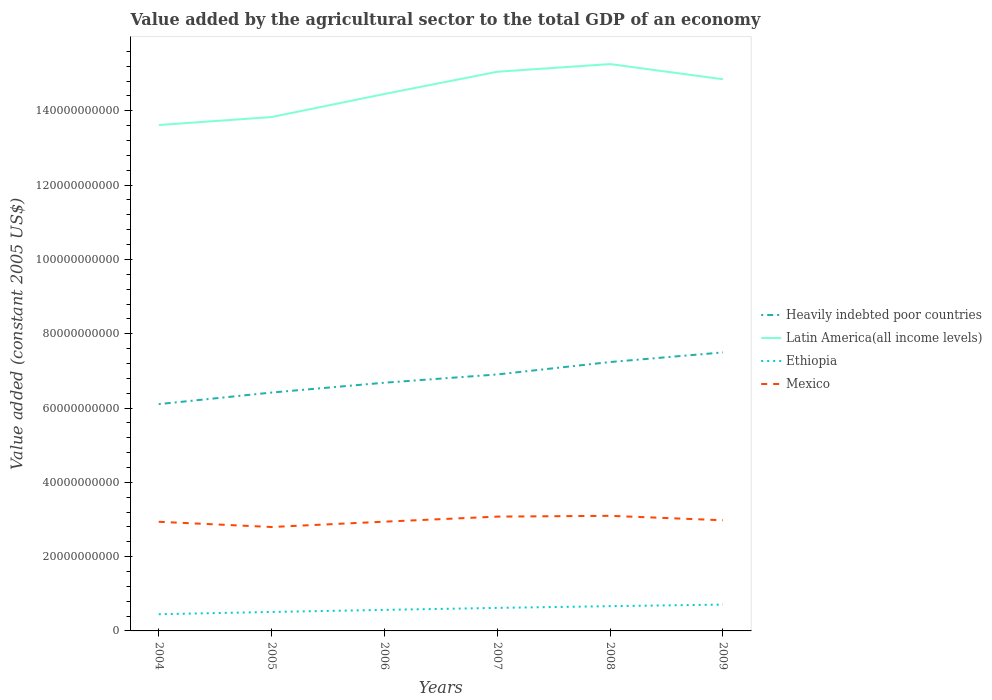Is the number of lines equal to the number of legend labels?
Offer a very short reply. Yes. Across all years, what is the maximum value added by the agricultural sector in Heavily indebted poor countries?
Make the answer very short. 6.10e+1. In which year was the value added by the agricultural sector in Mexico maximum?
Keep it short and to the point. 2005. What is the total value added by the agricultural sector in Mexico in the graph?
Keep it short and to the point. -2.11e+08. What is the difference between the highest and the second highest value added by the agricultural sector in Heavily indebted poor countries?
Offer a terse response. 1.39e+1. What is the difference between two consecutive major ticks on the Y-axis?
Ensure brevity in your answer.  2.00e+1. Where does the legend appear in the graph?
Your answer should be very brief. Center right. How many legend labels are there?
Your response must be concise. 4. What is the title of the graph?
Ensure brevity in your answer.  Value added by the agricultural sector to the total GDP of an economy. Does "Niger" appear as one of the legend labels in the graph?
Give a very brief answer. No. What is the label or title of the X-axis?
Provide a short and direct response. Years. What is the label or title of the Y-axis?
Offer a very short reply. Value added (constant 2005 US$). What is the Value added (constant 2005 US$) of Heavily indebted poor countries in 2004?
Give a very brief answer. 6.10e+1. What is the Value added (constant 2005 US$) in Latin America(all income levels) in 2004?
Give a very brief answer. 1.36e+11. What is the Value added (constant 2005 US$) in Ethiopia in 2004?
Your answer should be compact. 4.50e+09. What is the Value added (constant 2005 US$) in Mexico in 2004?
Offer a terse response. 2.94e+1. What is the Value added (constant 2005 US$) in Heavily indebted poor countries in 2005?
Provide a succinct answer. 6.42e+1. What is the Value added (constant 2005 US$) of Latin America(all income levels) in 2005?
Keep it short and to the point. 1.38e+11. What is the Value added (constant 2005 US$) of Ethiopia in 2005?
Keep it short and to the point. 5.11e+09. What is the Value added (constant 2005 US$) of Mexico in 2005?
Make the answer very short. 2.80e+1. What is the Value added (constant 2005 US$) of Heavily indebted poor countries in 2006?
Your response must be concise. 6.68e+1. What is the Value added (constant 2005 US$) in Latin America(all income levels) in 2006?
Provide a short and direct response. 1.45e+11. What is the Value added (constant 2005 US$) of Ethiopia in 2006?
Offer a terse response. 5.66e+09. What is the Value added (constant 2005 US$) in Mexico in 2006?
Your answer should be compact. 2.94e+1. What is the Value added (constant 2005 US$) of Heavily indebted poor countries in 2007?
Ensure brevity in your answer.  6.90e+1. What is the Value added (constant 2005 US$) of Latin America(all income levels) in 2007?
Ensure brevity in your answer.  1.51e+11. What is the Value added (constant 2005 US$) of Ethiopia in 2007?
Keep it short and to the point. 6.20e+09. What is the Value added (constant 2005 US$) in Mexico in 2007?
Ensure brevity in your answer.  3.08e+1. What is the Value added (constant 2005 US$) of Heavily indebted poor countries in 2008?
Ensure brevity in your answer.  7.24e+1. What is the Value added (constant 2005 US$) in Latin America(all income levels) in 2008?
Make the answer very short. 1.53e+11. What is the Value added (constant 2005 US$) in Ethiopia in 2008?
Give a very brief answer. 6.66e+09. What is the Value added (constant 2005 US$) in Mexico in 2008?
Make the answer very short. 3.10e+1. What is the Value added (constant 2005 US$) of Heavily indebted poor countries in 2009?
Your answer should be very brief. 7.50e+1. What is the Value added (constant 2005 US$) in Latin America(all income levels) in 2009?
Keep it short and to the point. 1.48e+11. What is the Value added (constant 2005 US$) in Ethiopia in 2009?
Make the answer very short. 7.09e+09. What is the Value added (constant 2005 US$) of Mexico in 2009?
Offer a terse response. 2.98e+1. Across all years, what is the maximum Value added (constant 2005 US$) of Heavily indebted poor countries?
Provide a succinct answer. 7.50e+1. Across all years, what is the maximum Value added (constant 2005 US$) in Latin America(all income levels)?
Your response must be concise. 1.53e+11. Across all years, what is the maximum Value added (constant 2005 US$) of Ethiopia?
Your response must be concise. 7.09e+09. Across all years, what is the maximum Value added (constant 2005 US$) in Mexico?
Give a very brief answer. 3.10e+1. Across all years, what is the minimum Value added (constant 2005 US$) of Heavily indebted poor countries?
Ensure brevity in your answer.  6.10e+1. Across all years, what is the minimum Value added (constant 2005 US$) of Latin America(all income levels)?
Give a very brief answer. 1.36e+11. Across all years, what is the minimum Value added (constant 2005 US$) of Ethiopia?
Your response must be concise. 4.50e+09. Across all years, what is the minimum Value added (constant 2005 US$) in Mexico?
Provide a short and direct response. 2.80e+1. What is the total Value added (constant 2005 US$) in Heavily indebted poor countries in the graph?
Give a very brief answer. 4.08e+11. What is the total Value added (constant 2005 US$) of Latin America(all income levels) in the graph?
Your answer should be very brief. 8.71e+11. What is the total Value added (constant 2005 US$) in Ethiopia in the graph?
Offer a very short reply. 3.52e+1. What is the total Value added (constant 2005 US$) in Mexico in the graph?
Ensure brevity in your answer.  1.78e+11. What is the difference between the Value added (constant 2005 US$) in Heavily indebted poor countries in 2004 and that in 2005?
Your answer should be very brief. -3.12e+09. What is the difference between the Value added (constant 2005 US$) of Latin America(all income levels) in 2004 and that in 2005?
Your answer should be very brief. -2.15e+09. What is the difference between the Value added (constant 2005 US$) of Ethiopia in 2004 and that in 2005?
Provide a succinct answer. -6.09e+08. What is the difference between the Value added (constant 2005 US$) of Mexico in 2004 and that in 2005?
Offer a terse response. 1.40e+09. What is the difference between the Value added (constant 2005 US$) of Heavily indebted poor countries in 2004 and that in 2006?
Ensure brevity in your answer.  -5.77e+09. What is the difference between the Value added (constant 2005 US$) of Latin America(all income levels) in 2004 and that in 2006?
Provide a short and direct response. -8.36e+09. What is the difference between the Value added (constant 2005 US$) of Ethiopia in 2004 and that in 2006?
Keep it short and to the point. -1.17e+09. What is the difference between the Value added (constant 2005 US$) in Mexico in 2004 and that in 2006?
Offer a terse response. -3.12e+07. What is the difference between the Value added (constant 2005 US$) in Heavily indebted poor countries in 2004 and that in 2007?
Give a very brief answer. -7.99e+09. What is the difference between the Value added (constant 2005 US$) in Latin America(all income levels) in 2004 and that in 2007?
Give a very brief answer. -1.43e+1. What is the difference between the Value added (constant 2005 US$) of Ethiopia in 2004 and that in 2007?
Keep it short and to the point. -1.70e+09. What is the difference between the Value added (constant 2005 US$) of Mexico in 2004 and that in 2007?
Your answer should be compact. -1.39e+09. What is the difference between the Value added (constant 2005 US$) of Heavily indebted poor countries in 2004 and that in 2008?
Provide a succinct answer. -1.13e+1. What is the difference between the Value added (constant 2005 US$) of Latin America(all income levels) in 2004 and that in 2008?
Offer a very short reply. -1.64e+1. What is the difference between the Value added (constant 2005 US$) in Ethiopia in 2004 and that in 2008?
Give a very brief answer. -2.17e+09. What is the difference between the Value added (constant 2005 US$) in Mexico in 2004 and that in 2008?
Keep it short and to the point. -1.60e+09. What is the difference between the Value added (constant 2005 US$) in Heavily indebted poor countries in 2004 and that in 2009?
Your response must be concise. -1.39e+1. What is the difference between the Value added (constant 2005 US$) in Latin America(all income levels) in 2004 and that in 2009?
Your response must be concise. -1.23e+1. What is the difference between the Value added (constant 2005 US$) of Ethiopia in 2004 and that in 2009?
Offer a terse response. -2.59e+09. What is the difference between the Value added (constant 2005 US$) of Mexico in 2004 and that in 2009?
Make the answer very short. -4.10e+08. What is the difference between the Value added (constant 2005 US$) in Heavily indebted poor countries in 2005 and that in 2006?
Make the answer very short. -2.65e+09. What is the difference between the Value added (constant 2005 US$) of Latin America(all income levels) in 2005 and that in 2006?
Keep it short and to the point. -6.21e+09. What is the difference between the Value added (constant 2005 US$) of Ethiopia in 2005 and that in 2006?
Provide a succinct answer. -5.57e+08. What is the difference between the Value added (constant 2005 US$) in Mexico in 2005 and that in 2006?
Offer a very short reply. -1.44e+09. What is the difference between the Value added (constant 2005 US$) in Heavily indebted poor countries in 2005 and that in 2007?
Your answer should be compact. -4.87e+09. What is the difference between the Value added (constant 2005 US$) of Latin America(all income levels) in 2005 and that in 2007?
Your answer should be very brief. -1.22e+1. What is the difference between the Value added (constant 2005 US$) in Ethiopia in 2005 and that in 2007?
Provide a short and direct response. -1.09e+09. What is the difference between the Value added (constant 2005 US$) in Mexico in 2005 and that in 2007?
Your response must be concise. -2.80e+09. What is the difference between the Value added (constant 2005 US$) in Heavily indebted poor countries in 2005 and that in 2008?
Offer a terse response. -8.21e+09. What is the difference between the Value added (constant 2005 US$) of Latin America(all income levels) in 2005 and that in 2008?
Your answer should be compact. -1.43e+1. What is the difference between the Value added (constant 2005 US$) of Ethiopia in 2005 and that in 2008?
Your response must be concise. -1.56e+09. What is the difference between the Value added (constant 2005 US$) in Mexico in 2005 and that in 2008?
Offer a terse response. -3.01e+09. What is the difference between the Value added (constant 2005 US$) in Heavily indebted poor countries in 2005 and that in 2009?
Make the answer very short. -1.08e+1. What is the difference between the Value added (constant 2005 US$) in Latin America(all income levels) in 2005 and that in 2009?
Your answer should be compact. -1.02e+1. What is the difference between the Value added (constant 2005 US$) in Ethiopia in 2005 and that in 2009?
Give a very brief answer. -1.98e+09. What is the difference between the Value added (constant 2005 US$) in Mexico in 2005 and that in 2009?
Your answer should be very brief. -1.81e+09. What is the difference between the Value added (constant 2005 US$) in Heavily indebted poor countries in 2006 and that in 2007?
Offer a terse response. -2.22e+09. What is the difference between the Value added (constant 2005 US$) in Latin America(all income levels) in 2006 and that in 2007?
Offer a terse response. -5.98e+09. What is the difference between the Value added (constant 2005 US$) in Ethiopia in 2006 and that in 2007?
Your response must be concise. -5.35e+08. What is the difference between the Value added (constant 2005 US$) of Mexico in 2006 and that in 2007?
Offer a very short reply. -1.36e+09. What is the difference between the Value added (constant 2005 US$) of Heavily indebted poor countries in 2006 and that in 2008?
Your answer should be very brief. -5.57e+09. What is the difference between the Value added (constant 2005 US$) in Latin America(all income levels) in 2006 and that in 2008?
Your answer should be compact. -8.05e+09. What is the difference between the Value added (constant 2005 US$) of Ethiopia in 2006 and that in 2008?
Keep it short and to the point. -1.00e+09. What is the difference between the Value added (constant 2005 US$) in Mexico in 2006 and that in 2008?
Your answer should be very brief. -1.57e+09. What is the difference between the Value added (constant 2005 US$) of Heavily indebted poor countries in 2006 and that in 2009?
Ensure brevity in your answer.  -8.16e+09. What is the difference between the Value added (constant 2005 US$) of Latin America(all income levels) in 2006 and that in 2009?
Make the answer very short. -3.96e+09. What is the difference between the Value added (constant 2005 US$) of Ethiopia in 2006 and that in 2009?
Provide a succinct answer. -1.42e+09. What is the difference between the Value added (constant 2005 US$) in Mexico in 2006 and that in 2009?
Your response must be concise. -3.79e+08. What is the difference between the Value added (constant 2005 US$) in Heavily indebted poor countries in 2007 and that in 2008?
Ensure brevity in your answer.  -3.34e+09. What is the difference between the Value added (constant 2005 US$) in Latin America(all income levels) in 2007 and that in 2008?
Provide a short and direct response. -2.07e+09. What is the difference between the Value added (constant 2005 US$) of Ethiopia in 2007 and that in 2008?
Your answer should be very brief. -4.65e+08. What is the difference between the Value added (constant 2005 US$) of Mexico in 2007 and that in 2008?
Ensure brevity in your answer.  -2.11e+08. What is the difference between the Value added (constant 2005 US$) in Heavily indebted poor countries in 2007 and that in 2009?
Offer a very short reply. -5.93e+09. What is the difference between the Value added (constant 2005 US$) of Latin America(all income levels) in 2007 and that in 2009?
Your answer should be very brief. 2.02e+09. What is the difference between the Value added (constant 2005 US$) of Ethiopia in 2007 and that in 2009?
Give a very brief answer. -8.89e+08. What is the difference between the Value added (constant 2005 US$) in Mexico in 2007 and that in 2009?
Ensure brevity in your answer.  9.82e+08. What is the difference between the Value added (constant 2005 US$) in Heavily indebted poor countries in 2008 and that in 2009?
Provide a succinct answer. -2.59e+09. What is the difference between the Value added (constant 2005 US$) in Latin America(all income levels) in 2008 and that in 2009?
Ensure brevity in your answer.  4.09e+09. What is the difference between the Value added (constant 2005 US$) in Ethiopia in 2008 and that in 2009?
Make the answer very short. -4.24e+08. What is the difference between the Value added (constant 2005 US$) of Mexico in 2008 and that in 2009?
Provide a succinct answer. 1.19e+09. What is the difference between the Value added (constant 2005 US$) of Heavily indebted poor countries in 2004 and the Value added (constant 2005 US$) of Latin America(all income levels) in 2005?
Ensure brevity in your answer.  -7.73e+1. What is the difference between the Value added (constant 2005 US$) of Heavily indebted poor countries in 2004 and the Value added (constant 2005 US$) of Ethiopia in 2005?
Provide a succinct answer. 5.59e+1. What is the difference between the Value added (constant 2005 US$) in Heavily indebted poor countries in 2004 and the Value added (constant 2005 US$) in Mexico in 2005?
Keep it short and to the point. 3.31e+1. What is the difference between the Value added (constant 2005 US$) of Latin America(all income levels) in 2004 and the Value added (constant 2005 US$) of Ethiopia in 2005?
Your response must be concise. 1.31e+11. What is the difference between the Value added (constant 2005 US$) of Latin America(all income levels) in 2004 and the Value added (constant 2005 US$) of Mexico in 2005?
Offer a very short reply. 1.08e+11. What is the difference between the Value added (constant 2005 US$) of Ethiopia in 2004 and the Value added (constant 2005 US$) of Mexico in 2005?
Your response must be concise. -2.35e+1. What is the difference between the Value added (constant 2005 US$) in Heavily indebted poor countries in 2004 and the Value added (constant 2005 US$) in Latin America(all income levels) in 2006?
Offer a terse response. -8.35e+1. What is the difference between the Value added (constant 2005 US$) of Heavily indebted poor countries in 2004 and the Value added (constant 2005 US$) of Ethiopia in 2006?
Provide a succinct answer. 5.54e+1. What is the difference between the Value added (constant 2005 US$) of Heavily indebted poor countries in 2004 and the Value added (constant 2005 US$) of Mexico in 2006?
Provide a succinct answer. 3.16e+1. What is the difference between the Value added (constant 2005 US$) in Latin America(all income levels) in 2004 and the Value added (constant 2005 US$) in Ethiopia in 2006?
Your answer should be very brief. 1.31e+11. What is the difference between the Value added (constant 2005 US$) of Latin America(all income levels) in 2004 and the Value added (constant 2005 US$) of Mexico in 2006?
Make the answer very short. 1.07e+11. What is the difference between the Value added (constant 2005 US$) in Ethiopia in 2004 and the Value added (constant 2005 US$) in Mexico in 2006?
Provide a short and direct response. -2.49e+1. What is the difference between the Value added (constant 2005 US$) of Heavily indebted poor countries in 2004 and the Value added (constant 2005 US$) of Latin America(all income levels) in 2007?
Keep it short and to the point. -8.95e+1. What is the difference between the Value added (constant 2005 US$) in Heavily indebted poor countries in 2004 and the Value added (constant 2005 US$) in Ethiopia in 2007?
Provide a succinct answer. 5.48e+1. What is the difference between the Value added (constant 2005 US$) in Heavily indebted poor countries in 2004 and the Value added (constant 2005 US$) in Mexico in 2007?
Offer a very short reply. 3.03e+1. What is the difference between the Value added (constant 2005 US$) in Latin America(all income levels) in 2004 and the Value added (constant 2005 US$) in Ethiopia in 2007?
Give a very brief answer. 1.30e+11. What is the difference between the Value added (constant 2005 US$) of Latin America(all income levels) in 2004 and the Value added (constant 2005 US$) of Mexico in 2007?
Your response must be concise. 1.05e+11. What is the difference between the Value added (constant 2005 US$) of Ethiopia in 2004 and the Value added (constant 2005 US$) of Mexico in 2007?
Provide a succinct answer. -2.63e+1. What is the difference between the Value added (constant 2005 US$) in Heavily indebted poor countries in 2004 and the Value added (constant 2005 US$) in Latin America(all income levels) in 2008?
Offer a very short reply. -9.15e+1. What is the difference between the Value added (constant 2005 US$) of Heavily indebted poor countries in 2004 and the Value added (constant 2005 US$) of Ethiopia in 2008?
Make the answer very short. 5.44e+1. What is the difference between the Value added (constant 2005 US$) of Heavily indebted poor countries in 2004 and the Value added (constant 2005 US$) of Mexico in 2008?
Provide a short and direct response. 3.01e+1. What is the difference between the Value added (constant 2005 US$) in Latin America(all income levels) in 2004 and the Value added (constant 2005 US$) in Ethiopia in 2008?
Provide a succinct answer. 1.30e+11. What is the difference between the Value added (constant 2005 US$) in Latin America(all income levels) in 2004 and the Value added (constant 2005 US$) in Mexico in 2008?
Offer a terse response. 1.05e+11. What is the difference between the Value added (constant 2005 US$) in Ethiopia in 2004 and the Value added (constant 2005 US$) in Mexico in 2008?
Make the answer very short. -2.65e+1. What is the difference between the Value added (constant 2005 US$) of Heavily indebted poor countries in 2004 and the Value added (constant 2005 US$) of Latin America(all income levels) in 2009?
Keep it short and to the point. -8.75e+1. What is the difference between the Value added (constant 2005 US$) in Heavily indebted poor countries in 2004 and the Value added (constant 2005 US$) in Ethiopia in 2009?
Offer a terse response. 5.40e+1. What is the difference between the Value added (constant 2005 US$) of Heavily indebted poor countries in 2004 and the Value added (constant 2005 US$) of Mexico in 2009?
Your response must be concise. 3.13e+1. What is the difference between the Value added (constant 2005 US$) in Latin America(all income levels) in 2004 and the Value added (constant 2005 US$) in Ethiopia in 2009?
Provide a succinct answer. 1.29e+11. What is the difference between the Value added (constant 2005 US$) in Latin America(all income levels) in 2004 and the Value added (constant 2005 US$) in Mexico in 2009?
Keep it short and to the point. 1.06e+11. What is the difference between the Value added (constant 2005 US$) in Ethiopia in 2004 and the Value added (constant 2005 US$) in Mexico in 2009?
Your answer should be very brief. -2.53e+1. What is the difference between the Value added (constant 2005 US$) in Heavily indebted poor countries in 2005 and the Value added (constant 2005 US$) in Latin America(all income levels) in 2006?
Ensure brevity in your answer.  -8.04e+1. What is the difference between the Value added (constant 2005 US$) of Heavily indebted poor countries in 2005 and the Value added (constant 2005 US$) of Ethiopia in 2006?
Make the answer very short. 5.85e+1. What is the difference between the Value added (constant 2005 US$) in Heavily indebted poor countries in 2005 and the Value added (constant 2005 US$) in Mexico in 2006?
Offer a terse response. 3.48e+1. What is the difference between the Value added (constant 2005 US$) of Latin America(all income levels) in 2005 and the Value added (constant 2005 US$) of Ethiopia in 2006?
Offer a terse response. 1.33e+11. What is the difference between the Value added (constant 2005 US$) of Latin America(all income levels) in 2005 and the Value added (constant 2005 US$) of Mexico in 2006?
Offer a very short reply. 1.09e+11. What is the difference between the Value added (constant 2005 US$) of Ethiopia in 2005 and the Value added (constant 2005 US$) of Mexico in 2006?
Offer a very short reply. -2.43e+1. What is the difference between the Value added (constant 2005 US$) of Heavily indebted poor countries in 2005 and the Value added (constant 2005 US$) of Latin America(all income levels) in 2007?
Ensure brevity in your answer.  -8.63e+1. What is the difference between the Value added (constant 2005 US$) of Heavily indebted poor countries in 2005 and the Value added (constant 2005 US$) of Ethiopia in 2007?
Make the answer very short. 5.80e+1. What is the difference between the Value added (constant 2005 US$) of Heavily indebted poor countries in 2005 and the Value added (constant 2005 US$) of Mexico in 2007?
Provide a succinct answer. 3.34e+1. What is the difference between the Value added (constant 2005 US$) in Latin America(all income levels) in 2005 and the Value added (constant 2005 US$) in Ethiopia in 2007?
Your response must be concise. 1.32e+11. What is the difference between the Value added (constant 2005 US$) of Latin America(all income levels) in 2005 and the Value added (constant 2005 US$) of Mexico in 2007?
Your answer should be very brief. 1.08e+11. What is the difference between the Value added (constant 2005 US$) of Ethiopia in 2005 and the Value added (constant 2005 US$) of Mexico in 2007?
Keep it short and to the point. -2.57e+1. What is the difference between the Value added (constant 2005 US$) of Heavily indebted poor countries in 2005 and the Value added (constant 2005 US$) of Latin America(all income levels) in 2008?
Keep it short and to the point. -8.84e+1. What is the difference between the Value added (constant 2005 US$) of Heavily indebted poor countries in 2005 and the Value added (constant 2005 US$) of Ethiopia in 2008?
Provide a succinct answer. 5.75e+1. What is the difference between the Value added (constant 2005 US$) in Heavily indebted poor countries in 2005 and the Value added (constant 2005 US$) in Mexico in 2008?
Your answer should be very brief. 3.32e+1. What is the difference between the Value added (constant 2005 US$) in Latin America(all income levels) in 2005 and the Value added (constant 2005 US$) in Ethiopia in 2008?
Ensure brevity in your answer.  1.32e+11. What is the difference between the Value added (constant 2005 US$) in Latin America(all income levels) in 2005 and the Value added (constant 2005 US$) in Mexico in 2008?
Make the answer very short. 1.07e+11. What is the difference between the Value added (constant 2005 US$) in Ethiopia in 2005 and the Value added (constant 2005 US$) in Mexico in 2008?
Offer a very short reply. -2.59e+1. What is the difference between the Value added (constant 2005 US$) of Heavily indebted poor countries in 2005 and the Value added (constant 2005 US$) of Latin America(all income levels) in 2009?
Offer a very short reply. -8.43e+1. What is the difference between the Value added (constant 2005 US$) of Heavily indebted poor countries in 2005 and the Value added (constant 2005 US$) of Ethiopia in 2009?
Your answer should be compact. 5.71e+1. What is the difference between the Value added (constant 2005 US$) in Heavily indebted poor countries in 2005 and the Value added (constant 2005 US$) in Mexico in 2009?
Make the answer very short. 3.44e+1. What is the difference between the Value added (constant 2005 US$) in Latin America(all income levels) in 2005 and the Value added (constant 2005 US$) in Ethiopia in 2009?
Provide a succinct answer. 1.31e+11. What is the difference between the Value added (constant 2005 US$) of Latin America(all income levels) in 2005 and the Value added (constant 2005 US$) of Mexico in 2009?
Your answer should be very brief. 1.09e+11. What is the difference between the Value added (constant 2005 US$) of Ethiopia in 2005 and the Value added (constant 2005 US$) of Mexico in 2009?
Give a very brief answer. -2.47e+1. What is the difference between the Value added (constant 2005 US$) in Heavily indebted poor countries in 2006 and the Value added (constant 2005 US$) in Latin America(all income levels) in 2007?
Offer a very short reply. -8.37e+1. What is the difference between the Value added (constant 2005 US$) in Heavily indebted poor countries in 2006 and the Value added (constant 2005 US$) in Ethiopia in 2007?
Your answer should be very brief. 6.06e+1. What is the difference between the Value added (constant 2005 US$) of Heavily indebted poor countries in 2006 and the Value added (constant 2005 US$) of Mexico in 2007?
Give a very brief answer. 3.60e+1. What is the difference between the Value added (constant 2005 US$) in Latin America(all income levels) in 2006 and the Value added (constant 2005 US$) in Ethiopia in 2007?
Offer a very short reply. 1.38e+11. What is the difference between the Value added (constant 2005 US$) of Latin America(all income levels) in 2006 and the Value added (constant 2005 US$) of Mexico in 2007?
Ensure brevity in your answer.  1.14e+11. What is the difference between the Value added (constant 2005 US$) in Ethiopia in 2006 and the Value added (constant 2005 US$) in Mexico in 2007?
Your answer should be compact. -2.51e+1. What is the difference between the Value added (constant 2005 US$) in Heavily indebted poor countries in 2006 and the Value added (constant 2005 US$) in Latin America(all income levels) in 2008?
Provide a succinct answer. -8.58e+1. What is the difference between the Value added (constant 2005 US$) in Heavily indebted poor countries in 2006 and the Value added (constant 2005 US$) in Ethiopia in 2008?
Give a very brief answer. 6.02e+1. What is the difference between the Value added (constant 2005 US$) in Heavily indebted poor countries in 2006 and the Value added (constant 2005 US$) in Mexico in 2008?
Your response must be concise. 3.58e+1. What is the difference between the Value added (constant 2005 US$) in Latin America(all income levels) in 2006 and the Value added (constant 2005 US$) in Ethiopia in 2008?
Give a very brief answer. 1.38e+11. What is the difference between the Value added (constant 2005 US$) of Latin America(all income levels) in 2006 and the Value added (constant 2005 US$) of Mexico in 2008?
Ensure brevity in your answer.  1.14e+11. What is the difference between the Value added (constant 2005 US$) in Ethiopia in 2006 and the Value added (constant 2005 US$) in Mexico in 2008?
Provide a short and direct response. -2.53e+1. What is the difference between the Value added (constant 2005 US$) in Heavily indebted poor countries in 2006 and the Value added (constant 2005 US$) in Latin America(all income levels) in 2009?
Your answer should be compact. -8.17e+1. What is the difference between the Value added (constant 2005 US$) of Heavily indebted poor countries in 2006 and the Value added (constant 2005 US$) of Ethiopia in 2009?
Keep it short and to the point. 5.97e+1. What is the difference between the Value added (constant 2005 US$) of Heavily indebted poor countries in 2006 and the Value added (constant 2005 US$) of Mexico in 2009?
Your answer should be compact. 3.70e+1. What is the difference between the Value added (constant 2005 US$) in Latin America(all income levels) in 2006 and the Value added (constant 2005 US$) in Ethiopia in 2009?
Make the answer very short. 1.37e+11. What is the difference between the Value added (constant 2005 US$) in Latin America(all income levels) in 2006 and the Value added (constant 2005 US$) in Mexico in 2009?
Provide a short and direct response. 1.15e+11. What is the difference between the Value added (constant 2005 US$) of Ethiopia in 2006 and the Value added (constant 2005 US$) of Mexico in 2009?
Offer a terse response. -2.41e+1. What is the difference between the Value added (constant 2005 US$) in Heavily indebted poor countries in 2007 and the Value added (constant 2005 US$) in Latin America(all income levels) in 2008?
Keep it short and to the point. -8.35e+1. What is the difference between the Value added (constant 2005 US$) in Heavily indebted poor countries in 2007 and the Value added (constant 2005 US$) in Ethiopia in 2008?
Your answer should be compact. 6.24e+1. What is the difference between the Value added (constant 2005 US$) of Heavily indebted poor countries in 2007 and the Value added (constant 2005 US$) of Mexico in 2008?
Offer a terse response. 3.81e+1. What is the difference between the Value added (constant 2005 US$) in Latin America(all income levels) in 2007 and the Value added (constant 2005 US$) in Ethiopia in 2008?
Your answer should be very brief. 1.44e+11. What is the difference between the Value added (constant 2005 US$) of Latin America(all income levels) in 2007 and the Value added (constant 2005 US$) of Mexico in 2008?
Keep it short and to the point. 1.20e+11. What is the difference between the Value added (constant 2005 US$) of Ethiopia in 2007 and the Value added (constant 2005 US$) of Mexico in 2008?
Offer a terse response. -2.48e+1. What is the difference between the Value added (constant 2005 US$) in Heavily indebted poor countries in 2007 and the Value added (constant 2005 US$) in Latin America(all income levels) in 2009?
Ensure brevity in your answer.  -7.95e+1. What is the difference between the Value added (constant 2005 US$) in Heavily indebted poor countries in 2007 and the Value added (constant 2005 US$) in Ethiopia in 2009?
Keep it short and to the point. 6.20e+1. What is the difference between the Value added (constant 2005 US$) of Heavily indebted poor countries in 2007 and the Value added (constant 2005 US$) of Mexico in 2009?
Provide a succinct answer. 3.93e+1. What is the difference between the Value added (constant 2005 US$) of Latin America(all income levels) in 2007 and the Value added (constant 2005 US$) of Ethiopia in 2009?
Ensure brevity in your answer.  1.43e+11. What is the difference between the Value added (constant 2005 US$) in Latin America(all income levels) in 2007 and the Value added (constant 2005 US$) in Mexico in 2009?
Offer a terse response. 1.21e+11. What is the difference between the Value added (constant 2005 US$) in Ethiopia in 2007 and the Value added (constant 2005 US$) in Mexico in 2009?
Give a very brief answer. -2.36e+1. What is the difference between the Value added (constant 2005 US$) of Heavily indebted poor countries in 2008 and the Value added (constant 2005 US$) of Latin America(all income levels) in 2009?
Your response must be concise. -7.61e+1. What is the difference between the Value added (constant 2005 US$) in Heavily indebted poor countries in 2008 and the Value added (constant 2005 US$) in Ethiopia in 2009?
Offer a terse response. 6.53e+1. What is the difference between the Value added (constant 2005 US$) of Heavily indebted poor countries in 2008 and the Value added (constant 2005 US$) of Mexico in 2009?
Offer a terse response. 4.26e+1. What is the difference between the Value added (constant 2005 US$) of Latin America(all income levels) in 2008 and the Value added (constant 2005 US$) of Ethiopia in 2009?
Give a very brief answer. 1.45e+11. What is the difference between the Value added (constant 2005 US$) of Latin America(all income levels) in 2008 and the Value added (constant 2005 US$) of Mexico in 2009?
Offer a very short reply. 1.23e+11. What is the difference between the Value added (constant 2005 US$) of Ethiopia in 2008 and the Value added (constant 2005 US$) of Mexico in 2009?
Ensure brevity in your answer.  -2.31e+1. What is the average Value added (constant 2005 US$) of Heavily indebted poor countries per year?
Keep it short and to the point. 6.81e+1. What is the average Value added (constant 2005 US$) of Latin America(all income levels) per year?
Give a very brief answer. 1.45e+11. What is the average Value added (constant 2005 US$) in Ethiopia per year?
Make the answer very short. 5.87e+09. What is the average Value added (constant 2005 US$) of Mexico per year?
Provide a short and direct response. 2.97e+1. In the year 2004, what is the difference between the Value added (constant 2005 US$) of Heavily indebted poor countries and Value added (constant 2005 US$) of Latin America(all income levels)?
Keep it short and to the point. -7.51e+1. In the year 2004, what is the difference between the Value added (constant 2005 US$) of Heavily indebted poor countries and Value added (constant 2005 US$) of Ethiopia?
Ensure brevity in your answer.  5.65e+1. In the year 2004, what is the difference between the Value added (constant 2005 US$) of Heavily indebted poor countries and Value added (constant 2005 US$) of Mexico?
Keep it short and to the point. 3.17e+1. In the year 2004, what is the difference between the Value added (constant 2005 US$) of Latin America(all income levels) and Value added (constant 2005 US$) of Ethiopia?
Offer a very short reply. 1.32e+11. In the year 2004, what is the difference between the Value added (constant 2005 US$) of Latin America(all income levels) and Value added (constant 2005 US$) of Mexico?
Keep it short and to the point. 1.07e+11. In the year 2004, what is the difference between the Value added (constant 2005 US$) in Ethiopia and Value added (constant 2005 US$) in Mexico?
Ensure brevity in your answer.  -2.49e+1. In the year 2005, what is the difference between the Value added (constant 2005 US$) of Heavily indebted poor countries and Value added (constant 2005 US$) of Latin America(all income levels)?
Ensure brevity in your answer.  -7.42e+1. In the year 2005, what is the difference between the Value added (constant 2005 US$) in Heavily indebted poor countries and Value added (constant 2005 US$) in Ethiopia?
Your answer should be compact. 5.91e+1. In the year 2005, what is the difference between the Value added (constant 2005 US$) in Heavily indebted poor countries and Value added (constant 2005 US$) in Mexico?
Ensure brevity in your answer.  3.62e+1. In the year 2005, what is the difference between the Value added (constant 2005 US$) of Latin America(all income levels) and Value added (constant 2005 US$) of Ethiopia?
Give a very brief answer. 1.33e+11. In the year 2005, what is the difference between the Value added (constant 2005 US$) in Latin America(all income levels) and Value added (constant 2005 US$) in Mexico?
Ensure brevity in your answer.  1.10e+11. In the year 2005, what is the difference between the Value added (constant 2005 US$) in Ethiopia and Value added (constant 2005 US$) in Mexico?
Make the answer very short. -2.29e+1. In the year 2006, what is the difference between the Value added (constant 2005 US$) of Heavily indebted poor countries and Value added (constant 2005 US$) of Latin America(all income levels)?
Your response must be concise. -7.77e+1. In the year 2006, what is the difference between the Value added (constant 2005 US$) of Heavily indebted poor countries and Value added (constant 2005 US$) of Ethiopia?
Your response must be concise. 6.12e+1. In the year 2006, what is the difference between the Value added (constant 2005 US$) in Heavily indebted poor countries and Value added (constant 2005 US$) in Mexico?
Keep it short and to the point. 3.74e+1. In the year 2006, what is the difference between the Value added (constant 2005 US$) in Latin America(all income levels) and Value added (constant 2005 US$) in Ethiopia?
Give a very brief answer. 1.39e+11. In the year 2006, what is the difference between the Value added (constant 2005 US$) of Latin America(all income levels) and Value added (constant 2005 US$) of Mexico?
Keep it short and to the point. 1.15e+11. In the year 2006, what is the difference between the Value added (constant 2005 US$) in Ethiopia and Value added (constant 2005 US$) in Mexico?
Offer a terse response. -2.37e+1. In the year 2007, what is the difference between the Value added (constant 2005 US$) in Heavily indebted poor countries and Value added (constant 2005 US$) in Latin America(all income levels)?
Your answer should be very brief. -8.15e+1. In the year 2007, what is the difference between the Value added (constant 2005 US$) in Heavily indebted poor countries and Value added (constant 2005 US$) in Ethiopia?
Your answer should be very brief. 6.28e+1. In the year 2007, what is the difference between the Value added (constant 2005 US$) of Heavily indebted poor countries and Value added (constant 2005 US$) of Mexico?
Give a very brief answer. 3.83e+1. In the year 2007, what is the difference between the Value added (constant 2005 US$) in Latin America(all income levels) and Value added (constant 2005 US$) in Ethiopia?
Provide a short and direct response. 1.44e+11. In the year 2007, what is the difference between the Value added (constant 2005 US$) of Latin America(all income levels) and Value added (constant 2005 US$) of Mexico?
Provide a succinct answer. 1.20e+11. In the year 2007, what is the difference between the Value added (constant 2005 US$) of Ethiopia and Value added (constant 2005 US$) of Mexico?
Offer a very short reply. -2.46e+1. In the year 2008, what is the difference between the Value added (constant 2005 US$) of Heavily indebted poor countries and Value added (constant 2005 US$) of Latin America(all income levels)?
Ensure brevity in your answer.  -8.02e+1. In the year 2008, what is the difference between the Value added (constant 2005 US$) of Heavily indebted poor countries and Value added (constant 2005 US$) of Ethiopia?
Give a very brief answer. 6.57e+1. In the year 2008, what is the difference between the Value added (constant 2005 US$) of Heavily indebted poor countries and Value added (constant 2005 US$) of Mexico?
Offer a very short reply. 4.14e+1. In the year 2008, what is the difference between the Value added (constant 2005 US$) in Latin America(all income levels) and Value added (constant 2005 US$) in Ethiopia?
Provide a short and direct response. 1.46e+11. In the year 2008, what is the difference between the Value added (constant 2005 US$) of Latin America(all income levels) and Value added (constant 2005 US$) of Mexico?
Provide a succinct answer. 1.22e+11. In the year 2008, what is the difference between the Value added (constant 2005 US$) in Ethiopia and Value added (constant 2005 US$) in Mexico?
Ensure brevity in your answer.  -2.43e+1. In the year 2009, what is the difference between the Value added (constant 2005 US$) in Heavily indebted poor countries and Value added (constant 2005 US$) in Latin America(all income levels)?
Your answer should be compact. -7.35e+1. In the year 2009, what is the difference between the Value added (constant 2005 US$) in Heavily indebted poor countries and Value added (constant 2005 US$) in Ethiopia?
Provide a short and direct response. 6.79e+1. In the year 2009, what is the difference between the Value added (constant 2005 US$) in Heavily indebted poor countries and Value added (constant 2005 US$) in Mexico?
Provide a succinct answer. 4.52e+1. In the year 2009, what is the difference between the Value added (constant 2005 US$) of Latin America(all income levels) and Value added (constant 2005 US$) of Ethiopia?
Your answer should be very brief. 1.41e+11. In the year 2009, what is the difference between the Value added (constant 2005 US$) of Latin America(all income levels) and Value added (constant 2005 US$) of Mexico?
Offer a very short reply. 1.19e+11. In the year 2009, what is the difference between the Value added (constant 2005 US$) of Ethiopia and Value added (constant 2005 US$) of Mexico?
Provide a succinct answer. -2.27e+1. What is the ratio of the Value added (constant 2005 US$) in Heavily indebted poor countries in 2004 to that in 2005?
Provide a short and direct response. 0.95. What is the ratio of the Value added (constant 2005 US$) of Latin America(all income levels) in 2004 to that in 2005?
Offer a very short reply. 0.98. What is the ratio of the Value added (constant 2005 US$) of Ethiopia in 2004 to that in 2005?
Keep it short and to the point. 0.88. What is the ratio of the Value added (constant 2005 US$) in Mexico in 2004 to that in 2005?
Your answer should be compact. 1.05. What is the ratio of the Value added (constant 2005 US$) of Heavily indebted poor countries in 2004 to that in 2006?
Provide a succinct answer. 0.91. What is the ratio of the Value added (constant 2005 US$) of Latin America(all income levels) in 2004 to that in 2006?
Provide a succinct answer. 0.94. What is the ratio of the Value added (constant 2005 US$) of Ethiopia in 2004 to that in 2006?
Keep it short and to the point. 0.79. What is the ratio of the Value added (constant 2005 US$) of Mexico in 2004 to that in 2006?
Provide a short and direct response. 1. What is the ratio of the Value added (constant 2005 US$) of Heavily indebted poor countries in 2004 to that in 2007?
Give a very brief answer. 0.88. What is the ratio of the Value added (constant 2005 US$) in Latin America(all income levels) in 2004 to that in 2007?
Your answer should be very brief. 0.9. What is the ratio of the Value added (constant 2005 US$) in Ethiopia in 2004 to that in 2007?
Make the answer very short. 0.73. What is the ratio of the Value added (constant 2005 US$) of Mexico in 2004 to that in 2007?
Provide a short and direct response. 0.95. What is the ratio of the Value added (constant 2005 US$) of Heavily indebted poor countries in 2004 to that in 2008?
Offer a terse response. 0.84. What is the ratio of the Value added (constant 2005 US$) of Latin America(all income levels) in 2004 to that in 2008?
Give a very brief answer. 0.89. What is the ratio of the Value added (constant 2005 US$) of Ethiopia in 2004 to that in 2008?
Provide a succinct answer. 0.67. What is the ratio of the Value added (constant 2005 US$) of Mexico in 2004 to that in 2008?
Make the answer very short. 0.95. What is the ratio of the Value added (constant 2005 US$) in Heavily indebted poor countries in 2004 to that in 2009?
Your answer should be very brief. 0.81. What is the ratio of the Value added (constant 2005 US$) in Latin America(all income levels) in 2004 to that in 2009?
Your answer should be compact. 0.92. What is the ratio of the Value added (constant 2005 US$) of Ethiopia in 2004 to that in 2009?
Your response must be concise. 0.63. What is the ratio of the Value added (constant 2005 US$) of Mexico in 2004 to that in 2009?
Offer a very short reply. 0.99. What is the ratio of the Value added (constant 2005 US$) of Heavily indebted poor countries in 2005 to that in 2006?
Make the answer very short. 0.96. What is the ratio of the Value added (constant 2005 US$) in Latin America(all income levels) in 2005 to that in 2006?
Your response must be concise. 0.96. What is the ratio of the Value added (constant 2005 US$) of Ethiopia in 2005 to that in 2006?
Your answer should be compact. 0.9. What is the ratio of the Value added (constant 2005 US$) in Mexico in 2005 to that in 2006?
Offer a terse response. 0.95. What is the ratio of the Value added (constant 2005 US$) of Heavily indebted poor countries in 2005 to that in 2007?
Give a very brief answer. 0.93. What is the ratio of the Value added (constant 2005 US$) of Latin America(all income levels) in 2005 to that in 2007?
Your answer should be compact. 0.92. What is the ratio of the Value added (constant 2005 US$) in Ethiopia in 2005 to that in 2007?
Provide a succinct answer. 0.82. What is the ratio of the Value added (constant 2005 US$) in Mexico in 2005 to that in 2007?
Keep it short and to the point. 0.91. What is the ratio of the Value added (constant 2005 US$) in Heavily indebted poor countries in 2005 to that in 2008?
Your answer should be compact. 0.89. What is the ratio of the Value added (constant 2005 US$) in Latin America(all income levels) in 2005 to that in 2008?
Make the answer very short. 0.91. What is the ratio of the Value added (constant 2005 US$) of Ethiopia in 2005 to that in 2008?
Your answer should be compact. 0.77. What is the ratio of the Value added (constant 2005 US$) in Mexico in 2005 to that in 2008?
Offer a very short reply. 0.9. What is the ratio of the Value added (constant 2005 US$) of Heavily indebted poor countries in 2005 to that in 2009?
Provide a succinct answer. 0.86. What is the ratio of the Value added (constant 2005 US$) in Latin America(all income levels) in 2005 to that in 2009?
Ensure brevity in your answer.  0.93. What is the ratio of the Value added (constant 2005 US$) in Ethiopia in 2005 to that in 2009?
Offer a terse response. 0.72. What is the ratio of the Value added (constant 2005 US$) in Mexico in 2005 to that in 2009?
Provide a short and direct response. 0.94. What is the ratio of the Value added (constant 2005 US$) of Heavily indebted poor countries in 2006 to that in 2007?
Offer a terse response. 0.97. What is the ratio of the Value added (constant 2005 US$) of Latin America(all income levels) in 2006 to that in 2007?
Give a very brief answer. 0.96. What is the ratio of the Value added (constant 2005 US$) in Ethiopia in 2006 to that in 2007?
Offer a terse response. 0.91. What is the ratio of the Value added (constant 2005 US$) of Mexico in 2006 to that in 2007?
Your answer should be very brief. 0.96. What is the ratio of the Value added (constant 2005 US$) in Heavily indebted poor countries in 2006 to that in 2008?
Your answer should be very brief. 0.92. What is the ratio of the Value added (constant 2005 US$) of Latin America(all income levels) in 2006 to that in 2008?
Offer a very short reply. 0.95. What is the ratio of the Value added (constant 2005 US$) in Ethiopia in 2006 to that in 2008?
Provide a succinct answer. 0.85. What is the ratio of the Value added (constant 2005 US$) in Mexico in 2006 to that in 2008?
Offer a very short reply. 0.95. What is the ratio of the Value added (constant 2005 US$) of Heavily indebted poor countries in 2006 to that in 2009?
Your answer should be compact. 0.89. What is the ratio of the Value added (constant 2005 US$) of Latin America(all income levels) in 2006 to that in 2009?
Your response must be concise. 0.97. What is the ratio of the Value added (constant 2005 US$) in Ethiopia in 2006 to that in 2009?
Your answer should be very brief. 0.8. What is the ratio of the Value added (constant 2005 US$) of Mexico in 2006 to that in 2009?
Keep it short and to the point. 0.99. What is the ratio of the Value added (constant 2005 US$) of Heavily indebted poor countries in 2007 to that in 2008?
Offer a terse response. 0.95. What is the ratio of the Value added (constant 2005 US$) in Latin America(all income levels) in 2007 to that in 2008?
Your response must be concise. 0.99. What is the ratio of the Value added (constant 2005 US$) in Ethiopia in 2007 to that in 2008?
Provide a short and direct response. 0.93. What is the ratio of the Value added (constant 2005 US$) of Heavily indebted poor countries in 2007 to that in 2009?
Your response must be concise. 0.92. What is the ratio of the Value added (constant 2005 US$) of Latin America(all income levels) in 2007 to that in 2009?
Make the answer very short. 1.01. What is the ratio of the Value added (constant 2005 US$) of Ethiopia in 2007 to that in 2009?
Give a very brief answer. 0.87. What is the ratio of the Value added (constant 2005 US$) of Mexico in 2007 to that in 2009?
Your answer should be very brief. 1.03. What is the ratio of the Value added (constant 2005 US$) of Heavily indebted poor countries in 2008 to that in 2009?
Provide a short and direct response. 0.97. What is the ratio of the Value added (constant 2005 US$) of Latin America(all income levels) in 2008 to that in 2009?
Provide a short and direct response. 1.03. What is the ratio of the Value added (constant 2005 US$) in Ethiopia in 2008 to that in 2009?
Your answer should be compact. 0.94. What is the ratio of the Value added (constant 2005 US$) of Mexico in 2008 to that in 2009?
Offer a terse response. 1.04. What is the difference between the highest and the second highest Value added (constant 2005 US$) in Heavily indebted poor countries?
Offer a very short reply. 2.59e+09. What is the difference between the highest and the second highest Value added (constant 2005 US$) in Latin America(all income levels)?
Your answer should be very brief. 2.07e+09. What is the difference between the highest and the second highest Value added (constant 2005 US$) in Ethiopia?
Your response must be concise. 4.24e+08. What is the difference between the highest and the second highest Value added (constant 2005 US$) of Mexico?
Give a very brief answer. 2.11e+08. What is the difference between the highest and the lowest Value added (constant 2005 US$) of Heavily indebted poor countries?
Offer a terse response. 1.39e+1. What is the difference between the highest and the lowest Value added (constant 2005 US$) in Latin America(all income levels)?
Provide a short and direct response. 1.64e+1. What is the difference between the highest and the lowest Value added (constant 2005 US$) in Ethiopia?
Offer a terse response. 2.59e+09. What is the difference between the highest and the lowest Value added (constant 2005 US$) in Mexico?
Keep it short and to the point. 3.01e+09. 